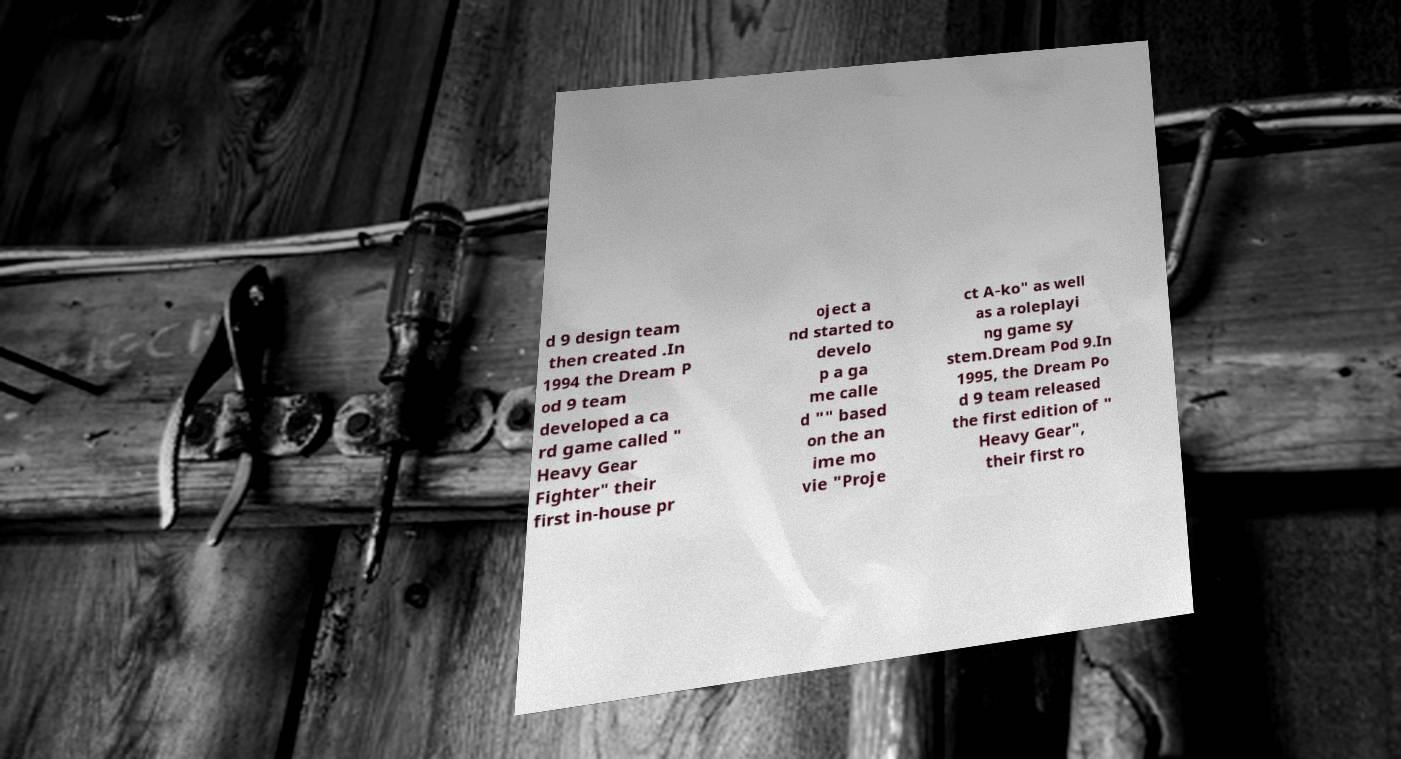Can you accurately transcribe the text from the provided image for me? d 9 design team then created .In 1994 the Dream P od 9 team developed a ca rd game called " Heavy Gear Fighter" their first in-house pr oject a nd started to develo p a ga me calle d "" based on the an ime mo vie "Proje ct A-ko" as well as a roleplayi ng game sy stem.Dream Pod 9.In 1995, the Dream Po d 9 team released the first edition of " Heavy Gear", their first ro 